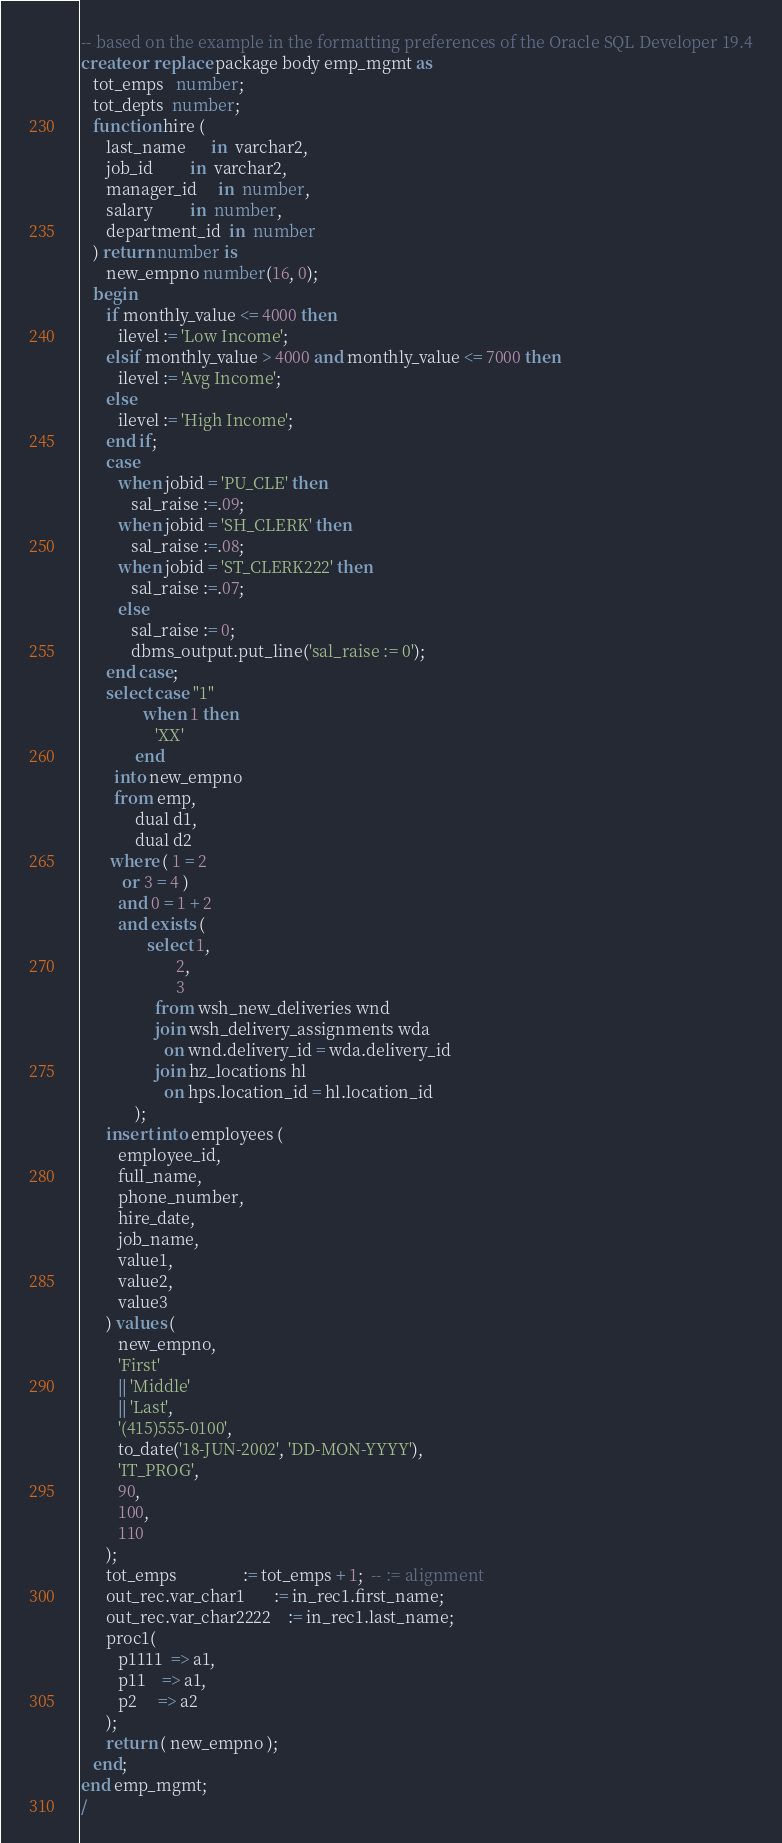Convert code to text. <code><loc_0><loc_0><loc_500><loc_500><_SQL_>-- based on the example in the formatting preferences of the Oracle SQL Developer 19.4
create or replace package body emp_mgmt as
   tot_emps   number;
   tot_depts  number;
   function hire (
      last_name      in  varchar2,
      job_id         in  varchar2,
      manager_id     in  number,
      salary         in  number,
      department_id  in  number
   ) return number is
      new_empno number(16, 0);
   begin
      if monthly_value <= 4000 then
         ilevel := 'Low Income';
      elsif monthly_value > 4000 and monthly_value <= 7000 then
         ilevel := 'Avg Income';
      else
         ilevel := 'High Income';
      end if;
      case
         when jobid = 'PU_CLE' then
            sal_raise :=.09;
         when jobid = 'SH_CLERK' then
            sal_raise :=.08;
         when jobid = 'ST_CLERK222' then
            sal_raise :=.07;
         else
            sal_raise := 0;
            dbms_output.put_line('sal_raise := 0');
      end case;
      select case "1"
               when 1 then
                  'XX'
             end
        into new_empno
        from emp,
             dual d1,
             dual d2
       where ( 1 = 2
          or 3 = 4 )
         and 0 = 1 + 2
         and exists (
                select 1,
                       2,
                       3
                  from wsh_new_deliveries wnd
                  join wsh_delivery_assignments wda
                    on wnd.delivery_id = wda.delivery_id
                  join hz_locations hl
                    on hps.location_id = hl.location_id
             );
      insert into employees (
         employee_id,
         full_name,
         phone_number,
         hire_date,
         job_name,
         value1,
         value2,
         value3
      ) values (
         new_empno,
         'First'
         || 'Middle'
         || 'Last',
         '(415)555-0100',
         to_date('18-JUN-2002', 'DD-MON-YYYY'),
         'IT_PROG',
         90,
         100,
         110
      );
      tot_emps                := tot_emps + 1;  -- := alignment
      out_rec.var_char1       := in_rec1.first_name;
      out_rec.var_char2222    := in_rec1.last_name;
      proc1(
         p1111  => a1,
         p11    => a1,
         p2     => a2
      );
      return ( new_empno );
   end;
end emp_mgmt;
/</code> 